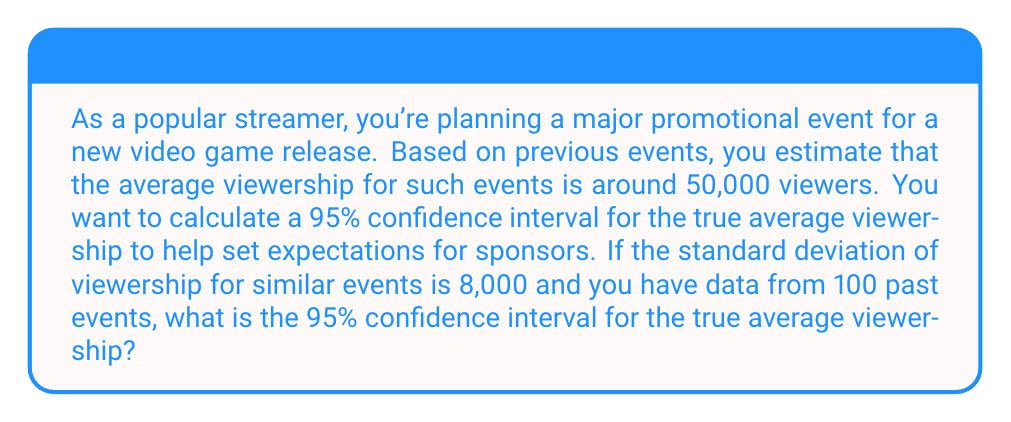Help me with this question. To calculate the confidence interval, we'll use the formula:

$$ \text{CI} = \bar{x} \pm z \cdot \frac{\sigma}{\sqrt{n}} $$

Where:
- $\bar{x}$ is the sample mean (50,000 viewers)
- $z$ is the z-score for 95% confidence (1.96)
- $\sigma$ is the standard deviation (8,000 viewers)
- $n$ is the sample size (100 events)

Steps:
1. Identify the values:
   $\bar{x} = 50,000$
   $z = 1.96$ (for 95% confidence)
   $\sigma = 8,000$
   $n = 100$

2. Calculate the standard error:
   $SE = \frac{\sigma}{\sqrt{n}} = \frac{8,000}{\sqrt{100}} = \frac{8,000}{10} = 800$

3. Calculate the margin of error:
   $ME = z \cdot SE = 1.96 \cdot 800 = 1,568$

4. Calculate the confidence interval:
   $\text{CI} = \bar{x} \pm ME$
   $\text{CI} = 50,000 \pm 1,568$
   $\text{CI} = (48,432, 51,568)$

Therefore, we can be 95% confident that the true average viewership for your streaming event will fall between 48,432 and 51,568 viewers.
Answer: (48,432, 51,568) viewers 